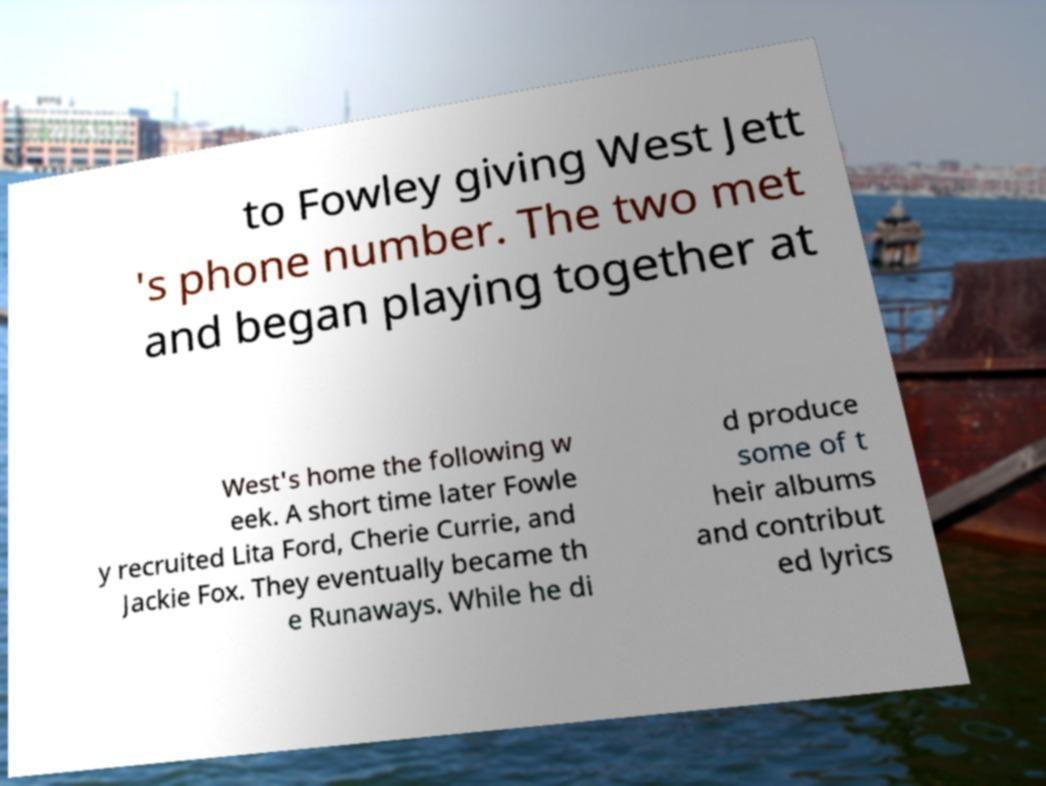Could you assist in decoding the text presented in this image and type it out clearly? to Fowley giving West Jett 's phone number. The two met and began playing together at West's home the following w eek. A short time later Fowle y recruited Lita Ford, Cherie Currie, and Jackie Fox. They eventually became th e Runaways. While he di d produce some of t heir albums and contribut ed lyrics 